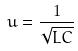<formula> <loc_0><loc_0><loc_500><loc_500>u = \frac { 1 } { \sqrt { L C } }</formula> 